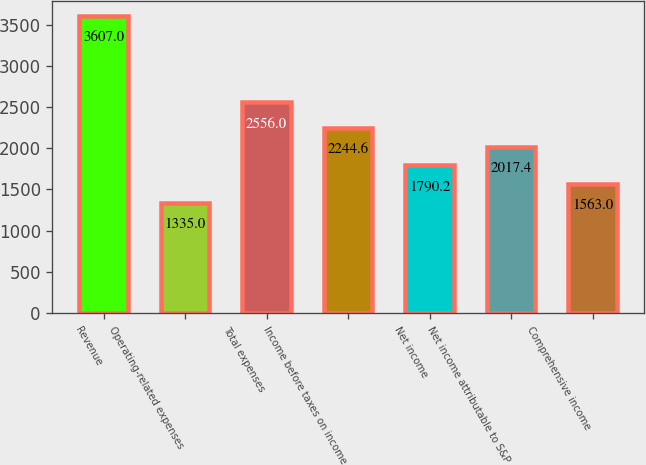<chart> <loc_0><loc_0><loc_500><loc_500><bar_chart><fcel>Revenue<fcel>Operating-related expenses<fcel>Total expenses<fcel>Income before taxes on income<fcel>Net income<fcel>Net income attributable to S&P<fcel>Comprehensive income<nl><fcel>3607<fcel>1335<fcel>2556<fcel>2244.6<fcel>1790.2<fcel>2017.4<fcel>1563<nl></chart> 